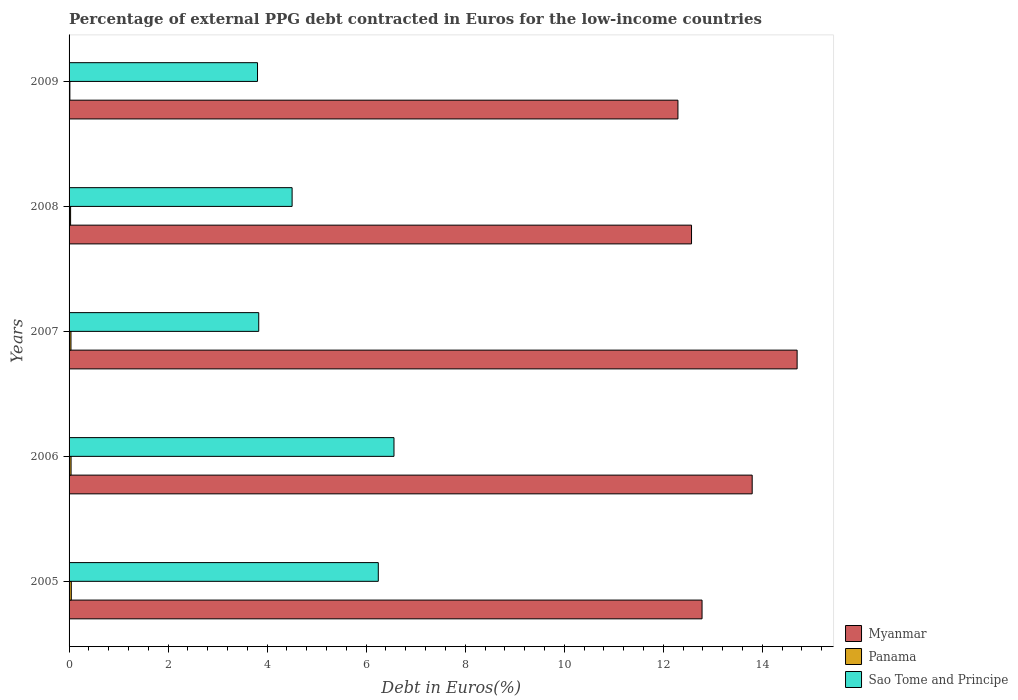How many groups of bars are there?
Make the answer very short. 5. Are the number of bars per tick equal to the number of legend labels?
Offer a terse response. Yes. Are the number of bars on each tick of the Y-axis equal?
Your answer should be very brief. Yes. How many bars are there on the 3rd tick from the top?
Your answer should be compact. 3. How many bars are there on the 3rd tick from the bottom?
Offer a terse response. 3. What is the percentage of external PPG debt contracted in Euros in Myanmar in 2005?
Offer a very short reply. 12.78. Across all years, what is the maximum percentage of external PPG debt contracted in Euros in Panama?
Ensure brevity in your answer.  0.04. Across all years, what is the minimum percentage of external PPG debt contracted in Euros in Myanmar?
Provide a short and direct response. 12.3. In which year was the percentage of external PPG debt contracted in Euros in Myanmar minimum?
Give a very brief answer. 2009. What is the total percentage of external PPG debt contracted in Euros in Panama in the graph?
Give a very brief answer. 0.17. What is the difference between the percentage of external PPG debt contracted in Euros in Panama in 2006 and that in 2009?
Offer a very short reply. 0.02. What is the difference between the percentage of external PPG debt contracted in Euros in Myanmar in 2006 and the percentage of external PPG debt contracted in Euros in Sao Tome and Principe in 2008?
Ensure brevity in your answer.  9.29. What is the average percentage of external PPG debt contracted in Euros in Sao Tome and Principe per year?
Your answer should be very brief. 4.99. In the year 2007, what is the difference between the percentage of external PPG debt contracted in Euros in Sao Tome and Principe and percentage of external PPG debt contracted in Euros in Panama?
Make the answer very short. 3.79. What is the ratio of the percentage of external PPG debt contracted in Euros in Sao Tome and Principe in 2006 to that in 2007?
Make the answer very short. 1.71. Is the percentage of external PPG debt contracted in Euros in Sao Tome and Principe in 2007 less than that in 2008?
Ensure brevity in your answer.  Yes. What is the difference between the highest and the second highest percentage of external PPG debt contracted in Euros in Myanmar?
Give a very brief answer. 0.91. What is the difference between the highest and the lowest percentage of external PPG debt contracted in Euros in Panama?
Provide a short and direct response. 0.03. In how many years, is the percentage of external PPG debt contracted in Euros in Sao Tome and Principe greater than the average percentage of external PPG debt contracted in Euros in Sao Tome and Principe taken over all years?
Give a very brief answer. 2. Is the sum of the percentage of external PPG debt contracted in Euros in Sao Tome and Principe in 2005 and 2008 greater than the maximum percentage of external PPG debt contracted in Euros in Panama across all years?
Provide a short and direct response. Yes. What does the 1st bar from the top in 2007 represents?
Keep it short and to the point. Sao Tome and Principe. What does the 3rd bar from the bottom in 2008 represents?
Give a very brief answer. Sao Tome and Principe. Is it the case that in every year, the sum of the percentage of external PPG debt contracted in Euros in Sao Tome and Principe and percentage of external PPG debt contracted in Euros in Myanmar is greater than the percentage of external PPG debt contracted in Euros in Panama?
Your answer should be compact. Yes. What is the difference between two consecutive major ticks on the X-axis?
Ensure brevity in your answer.  2. Are the values on the major ticks of X-axis written in scientific E-notation?
Your answer should be very brief. No. Does the graph contain any zero values?
Provide a succinct answer. No. Does the graph contain grids?
Your answer should be very brief. No. Where does the legend appear in the graph?
Make the answer very short. Bottom right. How many legend labels are there?
Provide a succinct answer. 3. What is the title of the graph?
Keep it short and to the point. Percentage of external PPG debt contracted in Euros for the low-income countries. Does "Kyrgyz Republic" appear as one of the legend labels in the graph?
Keep it short and to the point. No. What is the label or title of the X-axis?
Keep it short and to the point. Debt in Euros(%). What is the label or title of the Y-axis?
Provide a short and direct response. Years. What is the Debt in Euros(%) in Myanmar in 2005?
Give a very brief answer. 12.78. What is the Debt in Euros(%) of Panama in 2005?
Your answer should be compact. 0.04. What is the Debt in Euros(%) of Sao Tome and Principe in 2005?
Offer a very short reply. 6.24. What is the Debt in Euros(%) in Myanmar in 2006?
Provide a short and direct response. 13.8. What is the Debt in Euros(%) of Panama in 2006?
Make the answer very short. 0.04. What is the Debt in Euros(%) of Sao Tome and Principe in 2006?
Give a very brief answer. 6.56. What is the Debt in Euros(%) in Myanmar in 2007?
Offer a terse response. 14.7. What is the Debt in Euros(%) of Panama in 2007?
Keep it short and to the point. 0.04. What is the Debt in Euros(%) in Sao Tome and Principe in 2007?
Your response must be concise. 3.83. What is the Debt in Euros(%) of Myanmar in 2008?
Give a very brief answer. 12.57. What is the Debt in Euros(%) in Panama in 2008?
Make the answer very short. 0.03. What is the Debt in Euros(%) of Sao Tome and Principe in 2008?
Your answer should be very brief. 4.5. What is the Debt in Euros(%) in Myanmar in 2009?
Your response must be concise. 12.3. What is the Debt in Euros(%) of Panama in 2009?
Your response must be concise. 0.02. What is the Debt in Euros(%) of Sao Tome and Principe in 2009?
Ensure brevity in your answer.  3.81. Across all years, what is the maximum Debt in Euros(%) of Myanmar?
Your response must be concise. 14.7. Across all years, what is the maximum Debt in Euros(%) in Panama?
Your response must be concise. 0.04. Across all years, what is the maximum Debt in Euros(%) in Sao Tome and Principe?
Your response must be concise. 6.56. Across all years, what is the minimum Debt in Euros(%) of Myanmar?
Ensure brevity in your answer.  12.3. Across all years, what is the minimum Debt in Euros(%) of Panama?
Provide a short and direct response. 0.02. Across all years, what is the minimum Debt in Euros(%) in Sao Tome and Principe?
Keep it short and to the point. 3.81. What is the total Debt in Euros(%) of Myanmar in the graph?
Your answer should be compact. 66.15. What is the total Debt in Euros(%) in Panama in the graph?
Offer a terse response. 0.17. What is the total Debt in Euros(%) of Sao Tome and Principe in the graph?
Give a very brief answer. 24.95. What is the difference between the Debt in Euros(%) of Myanmar in 2005 and that in 2006?
Give a very brief answer. -1.01. What is the difference between the Debt in Euros(%) in Panama in 2005 and that in 2006?
Give a very brief answer. 0. What is the difference between the Debt in Euros(%) in Sao Tome and Principe in 2005 and that in 2006?
Keep it short and to the point. -0.32. What is the difference between the Debt in Euros(%) in Myanmar in 2005 and that in 2007?
Offer a very short reply. -1.92. What is the difference between the Debt in Euros(%) of Panama in 2005 and that in 2007?
Keep it short and to the point. 0.01. What is the difference between the Debt in Euros(%) of Sao Tome and Principe in 2005 and that in 2007?
Your answer should be compact. 2.41. What is the difference between the Debt in Euros(%) in Myanmar in 2005 and that in 2008?
Ensure brevity in your answer.  0.21. What is the difference between the Debt in Euros(%) in Panama in 2005 and that in 2008?
Your response must be concise. 0.01. What is the difference between the Debt in Euros(%) of Sao Tome and Principe in 2005 and that in 2008?
Your response must be concise. 1.74. What is the difference between the Debt in Euros(%) of Myanmar in 2005 and that in 2009?
Provide a short and direct response. 0.49. What is the difference between the Debt in Euros(%) in Panama in 2005 and that in 2009?
Your answer should be compact. 0.03. What is the difference between the Debt in Euros(%) of Sao Tome and Principe in 2005 and that in 2009?
Provide a succinct answer. 2.44. What is the difference between the Debt in Euros(%) in Myanmar in 2006 and that in 2007?
Your answer should be compact. -0.91. What is the difference between the Debt in Euros(%) of Panama in 2006 and that in 2007?
Provide a succinct answer. 0. What is the difference between the Debt in Euros(%) of Sao Tome and Principe in 2006 and that in 2007?
Your answer should be very brief. 2.73. What is the difference between the Debt in Euros(%) of Myanmar in 2006 and that in 2008?
Your answer should be compact. 1.23. What is the difference between the Debt in Euros(%) in Panama in 2006 and that in 2008?
Provide a short and direct response. 0.01. What is the difference between the Debt in Euros(%) in Sao Tome and Principe in 2006 and that in 2008?
Provide a short and direct response. 2.06. What is the difference between the Debt in Euros(%) in Myanmar in 2006 and that in 2009?
Your response must be concise. 1.5. What is the difference between the Debt in Euros(%) in Panama in 2006 and that in 2009?
Give a very brief answer. 0.02. What is the difference between the Debt in Euros(%) of Sao Tome and Principe in 2006 and that in 2009?
Provide a succinct answer. 2.76. What is the difference between the Debt in Euros(%) of Myanmar in 2007 and that in 2008?
Ensure brevity in your answer.  2.13. What is the difference between the Debt in Euros(%) in Panama in 2007 and that in 2008?
Keep it short and to the point. 0.01. What is the difference between the Debt in Euros(%) in Sao Tome and Principe in 2007 and that in 2008?
Offer a very short reply. -0.67. What is the difference between the Debt in Euros(%) of Myanmar in 2007 and that in 2009?
Offer a terse response. 2.41. What is the difference between the Debt in Euros(%) in Panama in 2007 and that in 2009?
Offer a terse response. 0.02. What is the difference between the Debt in Euros(%) of Sao Tome and Principe in 2007 and that in 2009?
Your answer should be compact. 0.02. What is the difference between the Debt in Euros(%) of Myanmar in 2008 and that in 2009?
Offer a very short reply. 0.27. What is the difference between the Debt in Euros(%) of Panama in 2008 and that in 2009?
Provide a succinct answer. 0.01. What is the difference between the Debt in Euros(%) in Sao Tome and Principe in 2008 and that in 2009?
Keep it short and to the point. 0.7. What is the difference between the Debt in Euros(%) in Myanmar in 2005 and the Debt in Euros(%) in Panama in 2006?
Offer a terse response. 12.74. What is the difference between the Debt in Euros(%) of Myanmar in 2005 and the Debt in Euros(%) of Sao Tome and Principe in 2006?
Provide a short and direct response. 6.22. What is the difference between the Debt in Euros(%) in Panama in 2005 and the Debt in Euros(%) in Sao Tome and Principe in 2006?
Your answer should be compact. -6.52. What is the difference between the Debt in Euros(%) in Myanmar in 2005 and the Debt in Euros(%) in Panama in 2007?
Provide a succinct answer. 12.74. What is the difference between the Debt in Euros(%) of Myanmar in 2005 and the Debt in Euros(%) of Sao Tome and Principe in 2007?
Your answer should be compact. 8.95. What is the difference between the Debt in Euros(%) in Panama in 2005 and the Debt in Euros(%) in Sao Tome and Principe in 2007?
Give a very brief answer. -3.79. What is the difference between the Debt in Euros(%) of Myanmar in 2005 and the Debt in Euros(%) of Panama in 2008?
Offer a terse response. 12.75. What is the difference between the Debt in Euros(%) of Myanmar in 2005 and the Debt in Euros(%) of Sao Tome and Principe in 2008?
Your answer should be compact. 8.28. What is the difference between the Debt in Euros(%) of Panama in 2005 and the Debt in Euros(%) of Sao Tome and Principe in 2008?
Offer a very short reply. -4.46. What is the difference between the Debt in Euros(%) in Myanmar in 2005 and the Debt in Euros(%) in Panama in 2009?
Provide a short and direct response. 12.77. What is the difference between the Debt in Euros(%) of Myanmar in 2005 and the Debt in Euros(%) of Sao Tome and Principe in 2009?
Ensure brevity in your answer.  8.98. What is the difference between the Debt in Euros(%) of Panama in 2005 and the Debt in Euros(%) of Sao Tome and Principe in 2009?
Provide a succinct answer. -3.76. What is the difference between the Debt in Euros(%) of Myanmar in 2006 and the Debt in Euros(%) of Panama in 2007?
Offer a very short reply. 13.76. What is the difference between the Debt in Euros(%) in Myanmar in 2006 and the Debt in Euros(%) in Sao Tome and Principe in 2007?
Provide a short and direct response. 9.96. What is the difference between the Debt in Euros(%) of Panama in 2006 and the Debt in Euros(%) of Sao Tome and Principe in 2007?
Give a very brief answer. -3.79. What is the difference between the Debt in Euros(%) in Myanmar in 2006 and the Debt in Euros(%) in Panama in 2008?
Ensure brevity in your answer.  13.76. What is the difference between the Debt in Euros(%) of Myanmar in 2006 and the Debt in Euros(%) of Sao Tome and Principe in 2008?
Provide a succinct answer. 9.29. What is the difference between the Debt in Euros(%) of Panama in 2006 and the Debt in Euros(%) of Sao Tome and Principe in 2008?
Your answer should be very brief. -4.46. What is the difference between the Debt in Euros(%) of Myanmar in 2006 and the Debt in Euros(%) of Panama in 2009?
Your response must be concise. 13.78. What is the difference between the Debt in Euros(%) in Myanmar in 2006 and the Debt in Euros(%) in Sao Tome and Principe in 2009?
Offer a very short reply. 9.99. What is the difference between the Debt in Euros(%) of Panama in 2006 and the Debt in Euros(%) of Sao Tome and Principe in 2009?
Offer a very short reply. -3.77. What is the difference between the Debt in Euros(%) of Myanmar in 2007 and the Debt in Euros(%) of Panama in 2008?
Your answer should be very brief. 14.67. What is the difference between the Debt in Euros(%) in Myanmar in 2007 and the Debt in Euros(%) in Sao Tome and Principe in 2008?
Your answer should be compact. 10.2. What is the difference between the Debt in Euros(%) of Panama in 2007 and the Debt in Euros(%) of Sao Tome and Principe in 2008?
Offer a terse response. -4.47. What is the difference between the Debt in Euros(%) of Myanmar in 2007 and the Debt in Euros(%) of Panama in 2009?
Keep it short and to the point. 14.69. What is the difference between the Debt in Euros(%) in Myanmar in 2007 and the Debt in Euros(%) in Sao Tome and Principe in 2009?
Make the answer very short. 10.9. What is the difference between the Debt in Euros(%) in Panama in 2007 and the Debt in Euros(%) in Sao Tome and Principe in 2009?
Give a very brief answer. -3.77. What is the difference between the Debt in Euros(%) of Myanmar in 2008 and the Debt in Euros(%) of Panama in 2009?
Offer a terse response. 12.55. What is the difference between the Debt in Euros(%) in Myanmar in 2008 and the Debt in Euros(%) in Sao Tome and Principe in 2009?
Your response must be concise. 8.76. What is the difference between the Debt in Euros(%) in Panama in 2008 and the Debt in Euros(%) in Sao Tome and Principe in 2009?
Your answer should be compact. -3.77. What is the average Debt in Euros(%) of Myanmar per year?
Ensure brevity in your answer.  13.23. What is the average Debt in Euros(%) of Panama per year?
Offer a very short reply. 0.03. What is the average Debt in Euros(%) in Sao Tome and Principe per year?
Offer a terse response. 4.99. In the year 2005, what is the difference between the Debt in Euros(%) in Myanmar and Debt in Euros(%) in Panama?
Give a very brief answer. 12.74. In the year 2005, what is the difference between the Debt in Euros(%) in Myanmar and Debt in Euros(%) in Sao Tome and Principe?
Your answer should be very brief. 6.54. In the year 2005, what is the difference between the Debt in Euros(%) in Panama and Debt in Euros(%) in Sao Tome and Principe?
Make the answer very short. -6.2. In the year 2006, what is the difference between the Debt in Euros(%) of Myanmar and Debt in Euros(%) of Panama?
Keep it short and to the point. 13.76. In the year 2006, what is the difference between the Debt in Euros(%) in Myanmar and Debt in Euros(%) in Sao Tome and Principe?
Your response must be concise. 7.23. In the year 2006, what is the difference between the Debt in Euros(%) in Panama and Debt in Euros(%) in Sao Tome and Principe?
Provide a short and direct response. -6.52. In the year 2007, what is the difference between the Debt in Euros(%) in Myanmar and Debt in Euros(%) in Panama?
Your answer should be very brief. 14.66. In the year 2007, what is the difference between the Debt in Euros(%) in Myanmar and Debt in Euros(%) in Sao Tome and Principe?
Make the answer very short. 10.87. In the year 2007, what is the difference between the Debt in Euros(%) in Panama and Debt in Euros(%) in Sao Tome and Principe?
Your answer should be very brief. -3.79. In the year 2008, what is the difference between the Debt in Euros(%) in Myanmar and Debt in Euros(%) in Panama?
Your answer should be very brief. 12.54. In the year 2008, what is the difference between the Debt in Euros(%) in Myanmar and Debt in Euros(%) in Sao Tome and Principe?
Offer a very short reply. 8.07. In the year 2008, what is the difference between the Debt in Euros(%) in Panama and Debt in Euros(%) in Sao Tome and Principe?
Your answer should be very brief. -4.47. In the year 2009, what is the difference between the Debt in Euros(%) of Myanmar and Debt in Euros(%) of Panama?
Your answer should be very brief. 12.28. In the year 2009, what is the difference between the Debt in Euros(%) in Myanmar and Debt in Euros(%) in Sao Tome and Principe?
Ensure brevity in your answer.  8.49. In the year 2009, what is the difference between the Debt in Euros(%) of Panama and Debt in Euros(%) of Sao Tome and Principe?
Ensure brevity in your answer.  -3.79. What is the ratio of the Debt in Euros(%) of Myanmar in 2005 to that in 2006?
Keep it short and to the point. 0.93. What is the ratio of the Debt in Euros(%) of Panama in 2005 to that in 2006?
Keep it short and to the point. 1.12. What is the ratio of the Debt in Euros(%) in Sao Tome and Principe in 2005 to that in 2006?
Make the answer very short. 0.95. What is the ratio of the Debt in Euros(%) in Myanmar in 2005 to that in 2007?
Make the answer very short. 0.87. What is the ratio of the Debt in Euros(%) in Panama in 2005 to that in 2007?
Offer a terse response. 1.17. What is the ratio of the Debt in Euros(%) in Sao Tome and Principe in 2005 to that in 2007?
Your response must be concise. 1.63. What is the ratio of the Debt in Euros(%) of Myanmar in 2005 to that in 2008?
Ensure brevity in your answer.  1.02. What is the ratio of the Debt in Euros(%) of Panama in 2005 to that in 2008?
Provide a succinct answer. 1.46. What is the ratio of the Debt in Euros(%) of Sao Tome and Principe in 2005 to that in 2008?
Provide a short and direct response. 1.39. What is the ratio of the Debt in Euros(%) of Myanmar in 2005 to that in 2009?
Keep it short and to the point. 1.04. What is the ratio of the Debt in Euros(%) of Panama in 2005 to that in 2009?
Your response must be concise. 2.75. What is the ratio of the Debt in Euros(%) in Sao Tome and Principe in 2005 to that in 2009?
Your answer should be very brief. 1.64. What is the ratio of the Debt in Euros(%) in Myanmar in 2006 to that in 2007?
Provide a short and direct response. 0.94. What is the ratio of the Debt in Euros(%) in Panama in 2006 to that in 2007?
Provide a succinct answer. 1.05. What is the ratio of the Debt in Euros(%) of Sao Tome and Principe in 2006 to that in 2007?
Make the answer very short. 1.71. What is the ratio of the Debt in Euros(%) in Myanmar in 2006 to that in 2008?
Give a very brief answer. 1.1. What is the ratio of the Debt in Euros(%) in Panama in 2006 to that in 2008?
Offer a very short reply. 1.31. What is the ratio of the Debt in Euros(%) in Sao Tome and Principe in 2006 to that in 2008?
Provide a succinct answer. 1.46. What is the ratio of the Debt in Euros(%) of Myanmar in 2006 to that in 2009?
Ensure brevity in your answer.  1.12. What is the ratio of the Debt in Euros(%) of Panama in 2006 to that in 2009?
Offer a terse response. 2.47. What is the ratio of the Debt in Euros(%) of Sao Tome and Principe in 2006 to that in 2009?
Offer a terse response. 1.72. What is the ratio of the Debt in Euros(%) of Myanmar in 2007 to that in 2008?
Your answer should be compact. 1.17. What is the ratio of the Debt in Euros(%) in Panama in 2007 to that in 2008?
Your answer should be very brief. 1.24. What is the ratio of the Debt in Euros(%) of Sao Tome and Principe in 2007 to that in 2008?
Make the answer very short. 0.85. What is the ratio of the Debt in Euros(%) in Myanmar in 2007 to that in 2009?
Keep it short and to the point. 1.2. What is the ratio of the Debt in Euros(%) of Panama in 2007 to that in 2009?
Your response must be concise. 2.35. What is the ratio of the Debt in Euros(%) of Sao Tome and Principe in 2007 to that in 2009?
Your response must be concise. 1.01. What is the ratio of the Debt in Euros(%) of Myanmar in 2008 to that in 2009?
Your answer should be very brief. 1.02. What is the ratio of the Debt in Euros(%) of Panama in 2008 to that in 2009?
Your answer should be very brief. 1.89. What is the ratio of the Debt in Euros(%) of Sao Tome and Principe in 2008 to that in 2009?
Your response must be concise. 1.18. What is the difference between the highest and the second highest Debt in Euros(%) in Myanmar?
Make the answer very short. 0.91. What is the difference between the highest and the second highest Debt in Euros(%) in Panama?
Give a very brief answer. 0. What is the difference between the highest and the second highest Debt in Euros(%) in Sao Tome and Principe?
Provide a succinct answer. 0.32. What is the difference between the highest and the lowest Debt in Euros(%) in Myanmar?
Make the answer very short. 2.41. What is the difference between the highest and the lowest Debt in Euros(%) of Panama?
Make the answer very short. 0.03. What is the difference between the highest and the lowest Debt in Euros(%) of Sao Tome and Principe?
Your answer should be very brief. 2.76. 